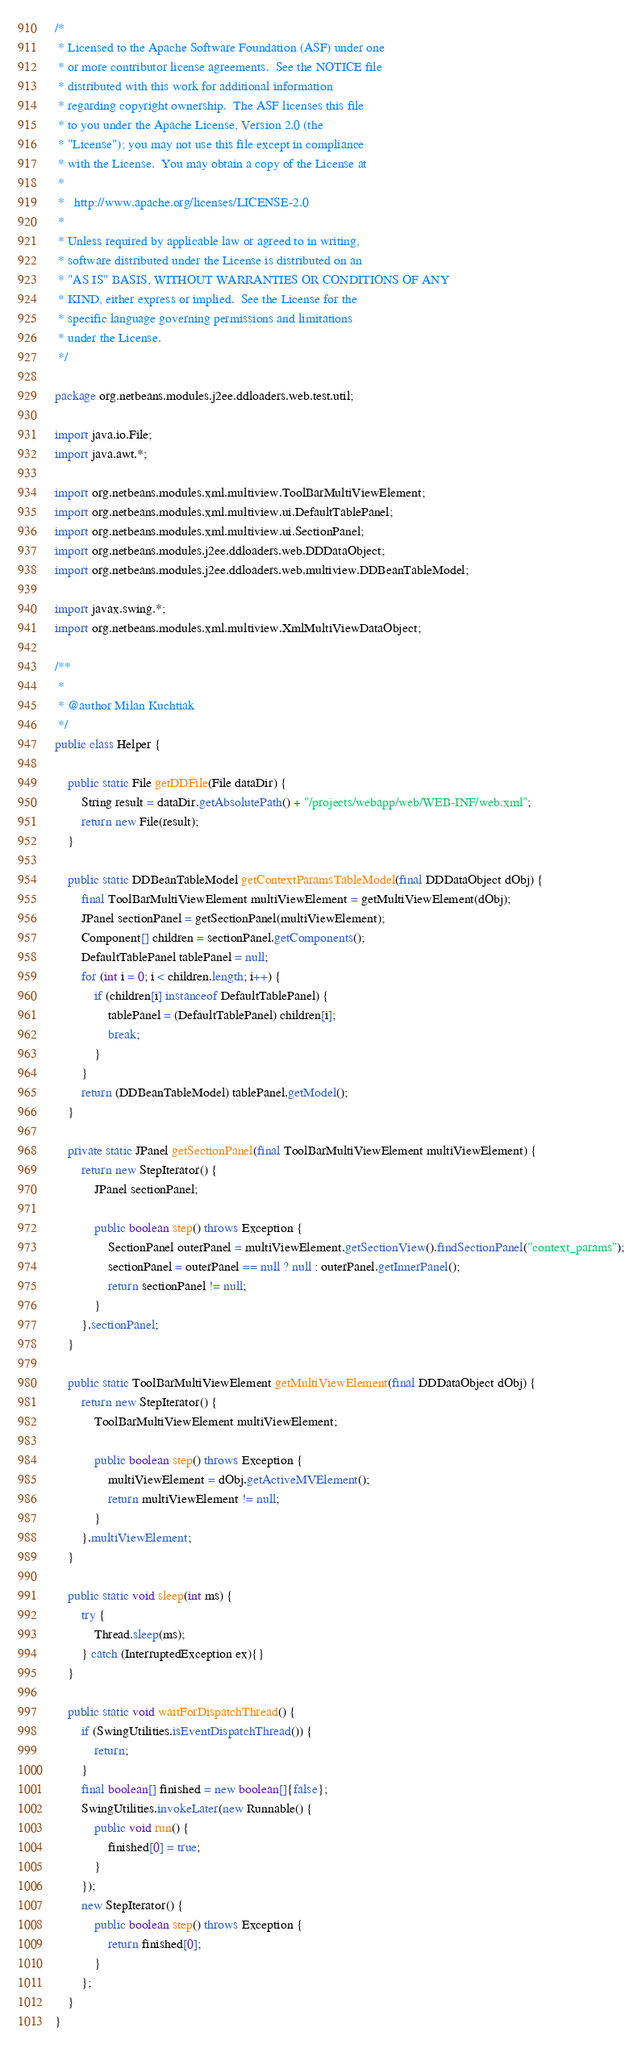<code> <loc_0><loc_0><loc_500><loc_500><_Java_>/*
 * Licensed to the Apache Software Foundation (ASF) under one
 * or more contributor license agreements.  See the NOTICE file
 * distributed with this work for additional information
 * regarding copyright ownership.  The ASF licenses this file
 * to you under the Apache License, Version 2.0 (the
 * "License"); you may not use this file except in compliance
 * with the License.  You may obtain a copy of the License at
 *
 *   http://www.apache.org/licenses/LICENSE-2.0
 *
 * Unless required by applicable law or agreed to in writing,
 * software distributed under the License is distributed on an
 * "AS IS" BASIS, WITHOUT WARRANTIES OR CONDITIONS OF ANY
 * KIND, either express or implied.  See the License for the
 * specific language governing permissions and limitations
 * under the License.
 */

package org.netbeans.modules.j2ee.ddloaders.web.test.util;

import java.io.File;
import java.awt.*;

import org.netbeans.modules.xml.multiview.ToolBarMultiViewElement;
import org.netbeans.modules.xml.multiview.ui.DefaultTablePanel;
import org.netbeans.modules.xml.multiview.ui.SectionPanel;
import org.netbeans.modules.j2ee.ddloaders.web.DDDataObject;
import org.netbeans.modules.j2ee.ddloaders.web.multiview.DDBeanTableModel;

import javax.swing.*;
import org.netbeans.modules.xml.multiview.XmlMultiViewDataObject;

/**
 *
 * @author Milan Kuchtiak
 */
public class Helper {

    public static File getDDFile(File dataDir) {
        String result = dataDir.getAbsolutePath() + "/projects/webapp/web/WEB-INF/web.xml";
        return new File(result);
    }

    public static DDBeanTableModel getContextParamsTableModel(final DDDataObject dObj) {
        final ToolBarMultiViewElement multiViewElement = getMultiViewElement(dObj);
        JPanel sectionPanel = getSectionPanel(multiViewElement);
        Component[] children = sectionPanel.getComponents();
        DefaultTablePanel tablePanel = null;
        for (int i = 0; i < children.length; i++) {
            if (children[i] instanceof DefaultTablePanel) {
                tablePanel = (DefaultTablePanel) children[i];
                break;
            }
        }
        return (DDBeanTableModel) tablePanel.getModel();
    }

    private static JPanel getSectionPanel(final ToolBarMultiViewElement multiViewElement) {
        return new StepIterator() {
            JPanel sectionPanel;

            public boolean step() throws Exception {
                SectionPanel outerPanel = multiViewElement.getSectionView().findSectionPanel("context_params");
                sectionPanel = outerPanel == null ? null : outerPanel.getInnerPanel();
                return sectionPanel != null;
            }
        }.sectionPanel;
    }

    public static ToolBarMultiViewElement getMultiViewElement(final DDDataObject dObj) {
        return new StepIterator() {
            ToolBarMultiViewElement multiViewElement;

            public boolean step() throws Exception {
                multiViewElement = dObj.getActiveMVElement();
                return multiViewElement != null;
            }
        }.multiViewElement;
    }

    public static void sleep(int ms) {
        try {
            Thread.sleep(ms);
        } catch (InterruptedException ex){}
    }

    public static void waitForDispatchThread() {
        if (SwingUtilities.isEventDispatchThread()) {
            return;
        }
        final boolean[] finished = new boolean[]{false};
        SwingUtilities.invokeLater(new Runnable() {
            public void run() {
                finished[0] = true;
            }
        });
        new StepIterator() {
            public boolean step() throws Exception {
                return finished[0];
            }
        };
    }
}
</code> 